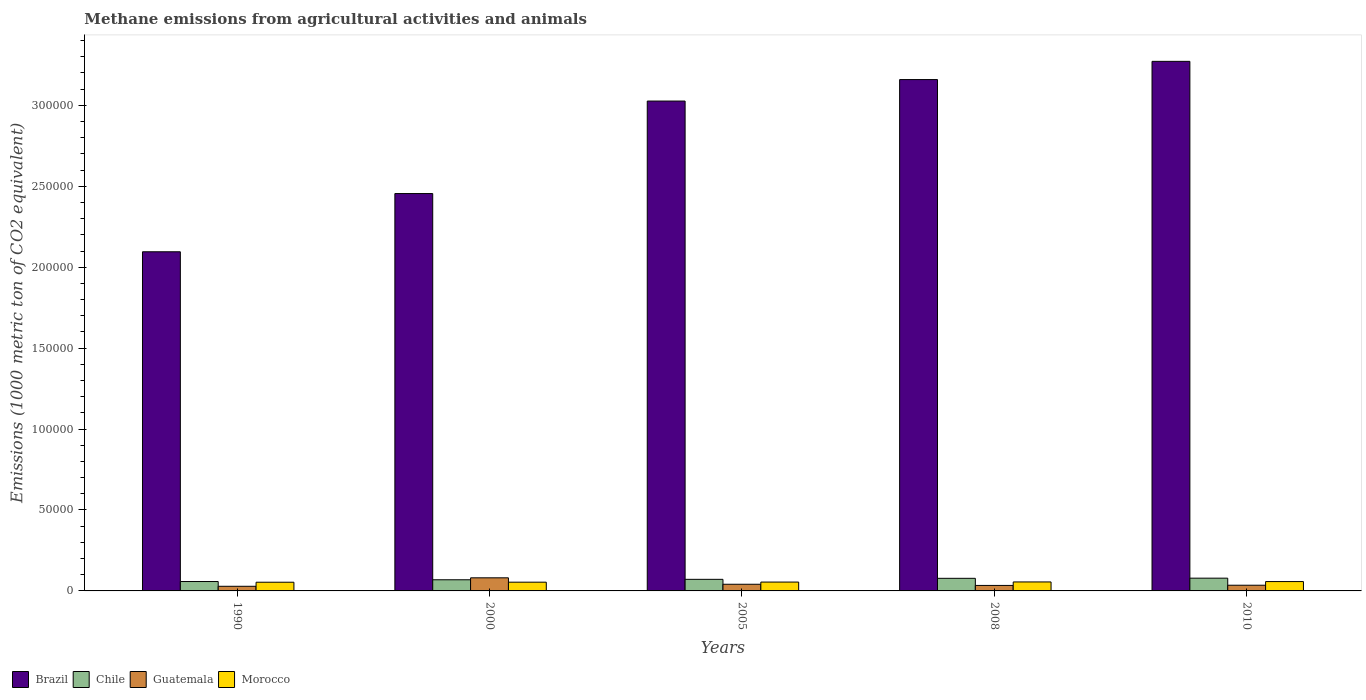How many different coloured bars are there?
Ensure brevity in your answer.  4. How many groups of bars are there?
Keep it short and to the point. 5. Are the number of bars per tick equal to the number of legend labels?
Ensure brevity in your answer.  Yes. Are the number of bars on each tick of the X-axis equal?
Provide a short and direct response. Yes. How many bars are there on the 1st tick from the left?
Provide a succinct answer. 4. What is the amount of methane emitted in Morocco in 1990?
Make the answer very short. 5368.8. Across all years, what is the maximum amount of methane emitted in Guatemala?
Give a very brief answer. 8089.2. Across all years, what is the minimum amount of methane emitted in Brazil?
Offer a terse response. 2.10e+05. What is the total amount of methane emitted in Guatemala in the graph?
Give a very brief answer. 2.20e+04. What is the difference between the amount of methane emitted in Guatemala in 1990 and that in 2010?
Your answer should be compact. -661. What is the difference between the amount of methane emitted in Brazil in 2008 and the amount of methane emitted in Morocco in 2010?
Your response must be concise. 3.10e+05. What is the average amount of methane emitted in Chile per year?
Offer a terse response. 7104.34. In the year 1990, what is the difference between the amount of methane emitted in Guatemala and amount of methane emitted in Morocco?
Keep it short and to the point. -2508.6. What is the ratio of the amount of methane emitted in Brazil in 2005 to that in 2008?
Your response must be concise. 0.96. Is the amount of methane emitted in Guatemala in 1990 less than that in 2000?
Your answer should be very brief. Yes. What is the difference between the highest and the second highest amount of methane emitted in Brazil?
Make the answer very short. 1.13e+04. What is the difference between the highest and the lowest amount of methane emitted in Morocco?
Ensure brevity in your answer.  410.3. Is the sum of the amount of methane emitted in Chile in 1990 and 2010 greater than the maximum amount of methane emitted in Guatemala across all years?
Provide a short and direct response. Yes. What does the 1st bar from the left in 1990 represents?
Make the answer very short. Brazil. Are all the bars in the graph horizontal?
Your response must be concise. No. How many years are there in the graph?
Provide a short and direct response. 5. Are the values on the major ticks of Y-axis written in scientific E-notation?
Provide a succinct answer. No. Does the graph contain any zero values?
Offer a terse response. No. Does the graph contain grids?
Offer a very short reply. No. Where does the legend appear in the graph?
Offer a terse response. Bottom left. What is the title of the graph?
Offer a terse response. Methane emissions from agricultural activities and animals. Does "Uganda" appear as one of the legend labels in the graph?
Ensure brevity in your answer.  No. What is the label or title of the Y-axis?
Provide a short and direct response. Emissions (1000 metric ton of CO2 equivalent). What is the Emissions (1000 metric ton of CO2 equivalent) of Brazil in 1990?
Your answer should be compact. 2.10e+05. What is the Emissions (1000 metric ton of CO2 equivalent) in Chile in 1990?
Give a very brief answer. 5805.8. What is the Emissions (1000 metric ton of CO2 equivalent) in Guatemala in 1990?
Offer a very short reply. 2860.2. What is the Emissions (1000 metric ton of CO2 equivalent) of Morocco in 1990?
Keep it short and to the point. 5368.8. What is the Emissions (1000 metric ton of CO2 equivalent) of Brazil in 2000?
Your answer should be very brief. 2.45e+05. What is the Emissions (1000 metric ton of CO2 equivalent) in Chile in 2000?
Provide a short and direct response. 6891.6. What is the Emissions (1000 metric ton of CO2 equivalent) of Guatemala in 2000?
Provide a succinct answer. 8089.2. What is the Emissions (1000 metric ton of CO2 equivalent) in Morocco in 2000?
Offer a terse response. 5400.3. What is the Emissions (1000 metric ton of CO2 equivalent) in Brazil in 2005?
Keep it short and to the point. 3.03e+05. What is the Emissions (1000 metric ton of CO2 equivalent) in Chile in 2005?
Offer a terse response. 7154.5. What is the Emissions (1000 metric ton of CO2 equivalent) of Guatemala in 2005?
Provide a short and direct response. 4120.8. What is the Emissions (1000 metric ton of CO2 equivalent) of Morocco in 2005?
Offer a terse response. 5471.4. What is the Emissions (1000 metric ton of CO2 equivalent) in Brazil in 2008?
Your response must be concise. 3.16e+05. What is the Emissions (1000 metric ton of CO2 equivalent) of Chile in 2008?
Offer a terse response. 7786.1. What is the Emissions (1000 metric ton of CO2 equivalent) in Guatemala in 2008?
Keep it short and to the point. 3394.9. What is the Emissions (1000 metric ton of CO2 equivalent) of Morocco in 2008?
Give a very brief answer. 5546.4. What is the Emissions (1000 metric ton of CO2 equivalent) of Brazil in 2010?
Offer a very short reply. 3.27e+05. What is the Emissions (1000 metric ton of CO2 equivalent) of Chile in 2010?
Your response must be concise. 7883.7. What is the Emissions (1000 metric ton of CO2 equivalent) of Guatemala in 2010?
Your answer should be compact. 3521.2. What is the Emissions (1000 metric ton of CO2 equivalent) in Morocco in 2010?
Offer a very short reply. 5779.1. Across all years, what is the maximum Emissions (1000 metric ton of CO2 equivalent) of Brazil?
Your response must be concise. 3.27e+05. Across all years, what is the maximum Emissions (1000 metric ton of CO2 equivalent) of Chile?
Offer a very short reply. 7883.7. Across all years, what is the maximum Emissions (1000 metric ton of CO2 equivalent) in Guatemala?
Give a very brief answer. 8089.2. Across all years, what is the maximum Emissions (1000 metric ton of CO2 equivalent) of Morocco?
Your answer should be compact. 5779.1. Across all years, what is the minimum Emissions (1000 metric ton of CO2 equivalent) in Brazil?
Provide a short and direct response. 2.10e+05. Across all years, what is the minimum Emissions (1000 metric ton of CO2 equivalent) in Chile?
Offer a very short reply. 5805.8. Across all years, what is the minimum Emissions (1000 metric ton of CO2 equivalent) in Guatemala?
Keep it short and to the point. 2860.2. Across all years, what is the minimum Emissions (1000 metric ton of CO2 equivalent) in Morocco?
Keep it short and to the point. 5368.8. What is the total Emissions (1000 metric ton of CO2 equivalent) in Brazil in the graph?
Offer a terse response. 1.40e+06. What is the total Emissions (1000 metric ton of CO2 equivalent) of Chile in the graph?
Give a very brief answer. 3.55e+04. What is the total Emissions (1000 metric ton of CO2 equivalent) of Guatemala in the graph?
Provide a short and direct response. 2.20e+04. What is the total Emissions (1000 metric ton of CO2 equivalent) of Morocco in the graph?
Provide a short and direct response. 2.76e+04. What is the difference between the Emissions (1000 metric ton of CO2 equivalent) of Brazil in 1990 and that in 2000?
Your answer should be compact. -3.60e+04. What is the difference between the Emissions (1000 metric ton of CO2 equivalent) in Chile in 1990 and that in 2000?
Keep it short and to the point. -1085.8. What is the difference between the Emissions (1000 metric ton of CO2 equivalent) in Guatemala in 1990 and that in 2000?
Give a very brief answer. -5229. What is the difference between the Emissions (1000 metric ton of CO2 equivalent) of Morocco in 1990 and that in 2000?
Offer a very short reply. -31.5. What is the difference between the Emissions (1000 metric ton of CO2 equivalent) in Brazil in 1990 and that in 2005?
Give a very brief answer. -9.31e+04. What is the difference between the Emissions (1000 metric ton of CO2 equivalent) in Chile in 1990 and that in 2005?
Your response must be concise. -1348.7. What is the difference between the Emissions (1000 metric ton of CO2 equivalent) in Guatemala in 1990 and that in 2005?
Offer a very short reply. -1260.6. What is the difference between the Emissions (1000 metric ton of CO2 equivalent) of Morocco in 1990 and that in 2005?
Your answer should be compact. -102.6. What is the difference between the Emissions (1000 metric ton of CO2 equivalent) in Brazil in 1990 and that in 2008?
Make the answer very short. -1.06e+05. What is the difference between the Emissions (1000 metric ton of CO2 equivalent) of Chile in 1990 and that in 2008?
Make the answer very short. -1980.3. What is the difference between the Emissions (1000 metric ton of CO2 equivalent) of Guatemala in 1990 and that in 2008?
Make the answer very short. -534.7. What is the difference between the Emissions (1000 metric ton of CO2 equivalent) of Morocco in 1990 and that in 2008?
Your response must be concise. -177.6. What is the difference between the Emissions (1000 metric ton of CO2 equivalent) in Brazil in 1990 and that in 2010?
Your answer should be very brief. -1.18e+05. What is the difference between the Emissions (1000 metric ton of CO2 equivalent) of Chile in 1990 and that in 2010?
Your answer should be very brief. -2077.9. What is the difference between the Emissions (1000 metric ton of CO2 equivalent) of Guatemala in 1990 and that in 2010?
Keep it short and to the point. -661. What is the difference between the Emissions (1000 metric ton of CO2 equivalent) in Morocco in 1990 and that in 2010?
Provide a short and direct response. -410.3. What is the difference between the Emissions (1000 metric ton of CO2 equivalent) in Brazil in 2000 and that in 2005?
Give a very brief answer. -5.71e+04. What is the difference between the Emissions (1000 metric ton of CO2 equivalent) in Chile in 2000 and that in 2005?
Your answer should be compact. -262.9. What is the difference between the Emissions (1000 metric ton of CO2 equivalent) of Guatemala in 2000 and that in 2005?
Give a very brief answer. 3968.4. What is the difference between the Emissions (1000 metric ton of CO2 equivalent) in Morocco in 2000 and that in 2005?
Your answer should be very brief. -71.1. What is the difference between the Emissions (1000 metric ton of CO2 equivalent) in Brazil in 2000 and that in 2008?
Your response must be concise. -7.04e+04. What is the difference between the Emissions (1000 metric ton of CO2 equivalent) in Chile in 2000 and that in 2008?
Provide a short and direct response. -894.5. What is the difference between the Emissions (1000 metric ton of CO2 equivalent) in Guatemala in 2000 and that in 2008?
Offer a terse response. 4694.3. What is the difference between the Emissions (1000 metric ton of CO2 equivalent) in Morocco in 2000 and that in 2008?
Give a very brief answer. -146.1. What is the difference between the Emissions (1000 metric ton of CO2 equivalent) of Brazil in 2000 and that in 2010?
Your response must be concise. -8.17e+04. What is the difference between the Emissions (1000 metric ton of CO2 equivalent) of Chile in 2000 and that in 2010?
Your answer should be compact. -992.1. What is the difference between the Emissions (1000 metric ton of CO2 equivalent) of Guatemala in 2000 and that in 2010?
Provide a succinct answer. 4568. What is the difference between the Emissions (1000 metric ton of CO2 equivalent) of Morocco in 2000 and that in 2010?
Your response must be concise. -378.8. What is the difference between the Emissions (1000 metric ton of CO2 equivalent) in Brazil in 2005 and that in 2008?
Provide a short and direct response. -1.33e+04. What is the difference between the Emissions (1000 metric ton of CO2 equivalent) of Chile in 2005 and that in 2008?
Make the answer very short. -631.6. What is the difference between the Emissions (1000 metric ton of CO2 equivalent) of Guatemala in 2005 and that in 2008?
Offer a terse response. 725.9. What is the difference between the Emissions (1000 metric ton of CO2 equivalent) in Morocco in 2005 and that in 2008?
Offer a very short reply. -75. What is the difference between the Emissions (1000 metric ton of CO2 equivalent) in Brazil in 2005 and that in 2010?
Make the answer very short. -2.45e+04. What is the difference between the Emissions (1000 metric ton of CO2 equivalent) of Chile in 2005 and that in 2010?
Your answer should be very brief. -729.2. What is the difference between the Emissions (1000 metric ton of CO2 equivalent) in Guatemala in 2005 and that in 2010?
Give a very brief answer. 599.6. What is the difference between the Emissions (1000 metric ton of CO2 equivalent) in Morocco in 2005 and that in 2010?
Make the answer very short. -307.7. What is the difference between the Emissions (1000 metric ton of CO2 equivalent) of Brazil in 2008 and that in 2010?
Offer a very short reply. -1.13e+04. What is the difference between the Emissions (1000 metric ton of CO2 equivalent) in Chile in 2008 and that in 2010?
Offer a very short reply. -97.6. What is the difference between the Emissions (1000 metric ton of CO2 equivalent) of Guatemala in 2008 and that in 2010?
Ensure brevity in your answer.  -126.3. What is the difference between the Emissions (1000 metric ton of CO2 equivalent) of Morocco in 2008 and that in 2010?
Give a very brief answer. -232.7. What is the difference between the Emissions (1000 metric ton of CO2 equivalent) in Brazil in 1990 and the Emissions (1000 metric ton of CO2 equivalent) in Chile in 2000?
Your response must be concise. 2.03e+05. What is the difference between the Emissions (1000 metric ton of CO2 equivalent) in Brazil in 1990 and the Emissions (1000 metric ton of CO2 equivalent) in Guatemala in 2000?
Ensure brevity in your answer.  2.01e+05. What is the difference between the Emissions (1000 metric ton of CO2 equivalent) in Brazil in 1990 and the Emissions (1000 metric ton of CO2 equivalent) in Morocco in 2000?
Offer a very short reply. 2.04e+05. What is the difference between the Emissions (1000 metric ton of CO2 equivalent) of Chile in 1990 and the Emissions (1000 metric ton of CO2 equivalent) of Guatemala in 2000?
Your response must be concise. -2283.4. What is the difference between the Emissions (1000 metric ton of CO2 equivalent) of Chile in 1990 and the Emissions (1000 metric ton of CO2 equivalent) of Morocco in 2000?
Offer a very short reply. 405.5. What is the difference between the Emissions (1000 metric ton of CO2 equivalent) in Guatemala in 1990 and the Emissions (1000 metric ton of CO2 equivalent) in Morocco in 2000?
Offer a terse response. -2540.1. What is the difference between the Emissions (1000 metric ton of CO2 equivalent) of Brazil in 1990 and the Emissions (1000 metric ton of CO2 equivalent) of Chile in 2005?
Offer a terse response. 2.02e+05. What is the difference between the Emissions (1000 metric ton of CO2 equivalent) in Brazil in 1990 and the Emissions (1000 metric ton of CO2 equivalent) in Guatemala in 2005?
Make the answer very short. 2.05e+05. What is the difference between the Emissions (1000 metric ton of CO2 equivalent) of Brazil in 1990 and the Emissions (1000 metric ton of CO2 equivalent) of Morocco in 2005?
Provide a succinct answer. 2.04e+05. What is the difference between the Emissions (1000 metric ton of CO2 equivalent) of Chile in 1990 and the Emissions (1000 metric ton of CO2 equivalent) of Guatemala in 2005?
Your answer should be compact. 1685. What is the difference between the Emissions (1000 metric ton of CO2 equivalent) of Chile in 1990 and the Emissions (1000 metric ton of CO2 equivalent) of Morocco in 2005?
Offer a very short reply. 334.4. What is the difference between the Emissions (1000 metric ton of CO2 equivalent) in Guatemala in 1990 and the Emissions (1000 metric ton of CO2 equivalent) in Morocco in 2005?
Your answer should be compact. -2611.2. What is the difference between the Emissions (1000 metric ton of CO2 equivalent) of Brazil in 1990 and the Emissions (1000 metric ton of CO2 equivalent) of Chile in 2008?
Your answer should be very brief. 2.02e+05. What is the difference between the Emissions (1000 metric ton of CO2 equivalent) of Brazil in 1990 and the Emissions (1000 metric ton of CO2 equivalent) of Guatemala in 2008?
Ensure brevity in your answer.  2.06e+05. What is the difference between the Emissions (1000 metric ton of CO2 equivalent) in Brazil in 1990 and the Emissions (1000 metric ton of CO2 equivalent) in Morocco in 2008?
Provide a short and direct response. 2.04e+05. What is the difference between the Emissions (1000 metric ton of CO2 equivalent) in Chile in 1990 and the Emissions (1000 metric ton of CO2 equivalent) in Guatemala in 2008?
Provide a short and direct response. 2410.9. What is the difference between the Emissions (1000 metric ton of CO2 equivalent) in Chile in 1990 and the Emissions (1000 metric ton of CO2 equivalent) in Morocco in 2008?
Provide a short and direct response. 259.4. What is the difference between the Emissions (1000 metric ton of CO2 equivalent) in Guatemala in 1990 and the Emissions (1000 metric ton of CO2 equivalent) in Morocco in 2008?
Offer a very short reply. -2686.2. What is the difference between the Emissions (1000 metric ton of CO2 equivalent) in Brazil in 1990 and the Emissions (1000 metric ton of CO2 equivalent) in Chile in 2010?
Offer a terse response. 2.02e+05. What is the difference between the Emissions (1000 metric ton of CO2 equivalent) of Brazil in 1990 and the Emissions (1000 metric ton of CO2 equivalent) of Guatemala in 2010?
Give a very brief answer. 2.06e+05. What is the difference between the Emissions (1000 metric ton of CO2 equivalent) in Brazil in 1990 and the Emissions (1000 metric ton of CO2 equivalent) in Morocco in 2010?
Offer a very short reply. 2.04e+05. What is the difference between the Emissions (1000 metric ton of CO2 equivalent) in Chile in 1990 and the Emissions (1000 metric ton of CO2 equivalent) in Guatemala in 2010?
Keep it short and to the point. 2284.6. What is the difference between the Emissions (1000 metric ton of CO2 equivalent) in Chile in 1990 and the Emissions (1000 metric ton of CO2 equivalent) in Morocco in 2010?
Your answer should be compact. 26.7. What is the difference between the Emissions (1000 metric ton of CO2 equivalent) of Guatemala in 1990 and the Emissions (1000 metric ton of CO2 equivalent) of Morocco in 2010?
Offer a very short reply. -2918.9. What is the difference between the Emissions (1000 metric ton of CO2 equivalent) in Brazil in 2000 and the Emissions (1000 metric ton of CO2 equivalent) in Chile in 2005?
Your response must be concise. 2.38e+05. What is the difference between the Emissions (1000 metric ton of CO2 equivalent) of Brazil in 2000 and the Emissions (1000 metric ton of CO2 equivalent) of Guatemala in 2005?
Offer a very short reply. 2.41e+05. What is the difference between the Emissions (1000 metric ton of CO2 equivalent) in Brazil in 2000 and the Emissions (1000 metric ton of CO2 equivalent) in Morocco in 2005?
Offer a very short reply. 2.40e+05. What is the difference between the Emissions (1000 metric ton of CO2 equivalent) of Chile in 2000 and the Emissions (1000 metric ton of CO2 equivalent) of Guatemala in 2005?
Provide a succinct answer. 2770.8. What is the difference between the Emissions (1000 metric ton of CO2 equivalent) of Chile in 2000 and the Emissions (1000 metric ton of CO2 equivalent) of Morocco in 2005?
Your response must be concise. 1420.2. What is the difference between the Emissions (1000 metric ton of CO2 equivalent) in Guatemala in 2000 and the Emissions (1000 metric ton of CO2 equivalent) in Morocco in 2005?
Keep it short and to the point. 2617.8. What is the difference between the Emissions (1000 metric ton of CO2 equivalent) in Brazil in 2000 and the Emissions (1000 metric ton of CO2 equivalent) in Chile in 2008?
Offer a very short reply. 2.38e+05. What is the difference between the Emissions (1000 metric ton of CO2 equivalent) of Brazil in 2000 and the Emissions (1000 metric ton of CO2 equivalent) of Guatemala in 2008?
Offer a terse response. 2.42e+05. What is the difference between the Emissions (1000 metric ton of CO2 equivalent) in Brazil in 2000 and the Emissions (1000 metric ton of CO2 equivalent) in Morocco in 2008?
Provide a succinct answer. 2.40e+05. What is the difference between the Emissions (1000 metric ton of CO2 equivalent) of Chile in 2000 and the Emissions (1000 metric ton of CO2 equivalent) of Guatemala in 2008?
Keep it short and to the point. 3496.7. What is the difference between the Emissions (1000 metric ton of CO2 equivalent) in Chile in 2000 and the Emissions (1000 metric ton of CO2 equivalent) in Morocco in 2008?
Provide a short and direct response. 1345.2. What is the difference between the Emissions (1000 metric ton of CO2 equivalent) of Guatemala in 2000 and the Emissions (1000 metric ton of CO2 equivalent) of Morocco in 2008?
Keep it short and to the point. 2542.8. What is the difference between the Emissions (1000 metric ton of CO2 equivalent) in Brazil in 2000 and the Emissions (1000 metric ton of CO2 equivalent) in Chile in 2010?
Provide a short and direct response. 2.38e+05. What is the difference between the Emissions (1000 metric ton of CO2 equivalent) of Brazil in 2000 and the Emissions (1000 metric ton of CO2 equivalent) of Guatemala in 2010?
Your answer should be compact. 2.42e+05. What is the difference between the Emissions (1000 metric ton of CO2 equivalent) in Brazil in 2000 and the Emissions (1000 metric ton of CO2 equivalent) in Morocco in 2010?
Your answer should be very brief. 2.40e+05. What is the difference between the Emissions (1000 metric ton of CO2 equivalent) of Chile in 2000 and the Emissions (1000 metric ton of CO2 equivalent) of Guatemala in 2010?
Give a very brief answer. 3370.4. What is the difference between the Emissions (1000 metric ton of CO2 equivalent) in Chile in 2000 and the Emissions (1000 metric ton of CO2 equivalent) in Morocco in 2010?
Your answer should be very brief. 1112.5. What is the difference between the Emissions (1000 metric ton of CO2 equivalent) of Guatemala in 2000 and the Emissions (1000 metric ton of CO2 equivalent) of Morocco in 2010?
Offer a terse response. 2310.1. What is the difference between the Emissions (1000 metric ton of CO2 equivalent) of Brazil in 2005 and the Emissions (1000 metric ton of CO2 equivalent) of Chile in 2008?
Make the answer very short. 2.95e+05. What is the difference between the Emissions (1000 metric ton of CO2 equivalent) of Brazil in 2005 and the Emissions (1000 metric ton of CO2 equivalent) of Guatemala in 2008?
Your answer should be very brief. 2.99e+05. What is the difference between the Emissions (1000 metric ton of CO2 equivalent) in Brazil in 2005 and the Emissions (1000 metric ton of CO2 equivalent) in Morocco in 2008?
Offer a terse response. 2.97e+05. What is the difference between the Emissions (1000 metric ton of CO2 equivalent) of Chile in 2005 and the Emissions (1000 metric ton of CO2 equivalent) of Guatemala in 2008?
Your answer should be very brief. 3759.6. What is the difference between the Emissions (1000 metric ton of CO2 equivalent) in Chile in 2005 and the Emissions (1000 metric ton of CO2 equivalent) in Morocco in 2008?
Provide a succinct answer. 1608.1. What is the difference between the Emissions (1000 metric ton of CO2 equivalent) in Guatemala in 2005 and the Emissions (1000 metric ton of CO2 equivalent) in Morocco in 2008?
Provide a succinct answer. -1425.6. What is the difference between the Emissions (1000 metric ton of CO2 equivalent) of Brazil in 2005 and the Emissions (1000 metric ton of CO2 equivalent) of Chile in 2010?
Keep it short and to the point. 2.95e+05. What is the difference between the Emissions (1000 metric ton of CO2 equivalent) in Brazil in 2005 and the Emissions (1000 metric ton of CO2 equivalent) in Guatemala in 2010?
Ensure brevity in your answer.  2.99e+05. What is the difference between the Emissions (1000 metric ton of CO2 equivalent) of Brazil in 2005 and the Emissions (1000 metric ton of CO2 equivalent) of Morocco in 2010?
Make the answer very short. 2.97e+05. What is the difference between the Emissions (1000 metric ton of CO2 equivalent) in Chile in 2005 and the Emissions (1000 metric ton of CO2 equivalent) in Guatemala in 2010?
Give a very brief answer. 3633.3. What is the difference between the Emissions (1000 metric ton of CO2 equivalent) in Chile in 2005 and the Emissions (1000 metric ton of CO2 equivalent) in Morocco in 2010?
Make the answer very short. 1375.4. What is the difference between the Emissions (1000 metric ton of CO2 equivalent) in Guatemala in 2005 and the Emissions (1000 metric ton of CO2 equivalent) in Morocco in 2010?
Keep it short and to the point. -1658.3. What is the difference between the Emissions (1000 metric ton of CO2 equivalent) of Brazil in 2008 and the Emissions (1000 metric ton of CO2 equivalent) of Chile in 2010?
Your answer should be compact. 3.08e+05. What is the difference between the Emissions (1000 metric ton of CO2 equivalent) in Brazil in 2008 and the Emissions (1000 metric ton of CO2 equivalent) in Guatemala in 2010?
Ensure brevity in your answer.  3.12e+05. What is the difference between the Emissions (1000 metric ton of CO2 equivalent) in Brazil in 2008 and the Emissions (1000 metric ton of CO2 equivalent) in Morocco in 2010?
Ensure brevity in your answer.  3.10e+05. What is the difference between the Emissions (1000 metric ton of CO2 equivalent) of Chile in 2008 and the Emissions (1000 metric ton of CO2 equivalent) of Guatemala in 2010?
Give a very brief answer. 4264.9. What is the difference between the Emissions (1000 metric ton of CO2 equivalent) in Chile in 2008 and the Emissions (1000 metric ton of CO2 equivalent) in Morocco in 2010?
Your answer should be compact. 2007. What is the difference between the Emissions (1000 metric ton of CO2 equivalent) of Guatemala in 2008 and the Emissions (1000 metric ton of CO2 equivalent) of Morocco in 2010?
Provide a succinct answer. -2384.2. What is the average Emissions (1000 metric ton of CO2 equivalent) in Brazil per year?
Ensure brevity in your answer.  2.80e+05. What is the average Emissions (1000 metric ton of CO2 equivalent) in Chile per year?
Offer a very short reply. 7104.34. What is the average Emissions (1000 metric ton of CO2 equivalent) in Guatemala per year?
Keep it short and to the point. 4397.26. What is the average Emissions (1000 metric ton of CO2 equivalent) of Morocco per year?
Offer a very short reply. 5513.2. In the year 1990, what is the difference between the Emissions (1000 metric ton of CO2 equivalent) in Brazil and Emissions (1000 metric ton of CO2 equivalent) in Chile?
Your answer should be very brief. 2.04e+05. In the year 1990, what is the difference between the Emissions (1000 metric ton of CO2 equivalent) of Brazil and Emissions (1000 metric ton of CO2 equivalent) of Guatemala?
Make the answer very short. 2.07e+05. In the year 1990, what is the difference between the Emissions (1000 metric ton of CO2 equivalent) of Brazil and Emissions (1000 metric ton of CO2 equivalent) of Morocco?
Offer a terse response. 2.04e+05. In the year 1990, what is the difference between the Emissions (1000 metric ton of CO2 equivalent) of Chile and Emissions (1000 metric ton of CO2 equivalent) of Guatemala?
Offer a terse response. 2945.6. In the year 1990, what is the difference between the Emissions (1000 metric ton of CO2 equivalent) of Chile and Emissions (1000 metric ton of CO2 equivalent) of Morocco?
Ensure brevity in your answer.  437. In the year 1990, what is the difference between the Emissions (1000 metric ton of CO2 equivalent) in Guatemala and Emissions (1000 metric ton of CO2 equivalent) in Morocco?
Provide a short and direct response. -2508.6. In the year 2000, what is the difference between the Emissions (1000 metric ton of CO2 equivalent) of Brazil and Emissions (1000 metric ton of CO2 equivalent) of Chile?
Your response must be concise. 2.39e+05. In the year 2000, what is the difference between the Emissions (1000 metric ton of CO2 equivalent) in Brazil and Emissions (1000 metric ton of CO2 equivalent) in Guatemala?
Your response must be concise. 2.37e+05. In the year 2000, what is the difference between the Emissions (1000 metric ton of CO2 equivalent) in Brazil and Emissions (1000 metric ton of CO2 equivalent) in Morocco?
Make the answer very short. 2.40e+05. In the year 2000, what is the difference between the Emissions (1000 metric ton of CO2 equivalent) of Chile and Emissions (1000 metric ton of CO2 equivalent) of Guatemala?
Your answer should be very brief. -1197.6. In the year 2000, what is the difference between the Emissions (1000 metric ton of CO2 equivalent) of Chile and Emissions (1000 metric ton of CO2 equivalent) of Morocco?
Provide a short and direct response. 1491.3. In the year 2000, what is the difference between the Emissions (1000 metric ton of CO2 equivalent) of Guatemala and Emissions (1000 metric ton of CO2 equivalent) of Morocco?
Provide a succinct answer. 2688.9. In the year 2005, what is the difference between the Emissions (1000 metric ton of CO2 equivalent) in Brazil and Emissions (1000 metric ton of CO2 equivalent) in Chile?
Your response must be concise. 2.95e+05. In the year 2005, what is the difference between the Emissions (1000 metric ton of CO2 equivalent) of Brazil and Emissions (1000 metric ton of CO2 equivalent) of Guatemala?
Make the answer very short. 2.99e+05. In the year 2005, what is the difference between the Emissions (1000 metric ton of CO2 equivalent) of Brazil and Emissions (1000 metric ton of CO2 equivalent) of Morocco?
Provide a short and direct response. 2.97e+05. In the year 2005, what is the difference between the Emissions (1000 metric ton of CO2 equivalent) in Chile and Emissions (1000 metric ton of CO2 equivalent) in Guatemala?
Provide a succinct answer. 3033.7. In the year 2005, what is the difference between the Emissions (1000 metric ton of CO2 equivalent) of Chile and Emissions (1000 metric ton of CO2 equivalent) of Morocco?
Offer a very short reply. 1683.1. In the year 2005, what is the difference between the Emissions (1000 metric ton of CO2 equivalent) in Guatemala and Emissions (1000 metric ton of CO2 equivalent) in Morocco?
Your response must be concise. -1350.6. In the year 2008, what is the difference between the Emissions (1000 metric ton of CO2 equivalent) in Brazil and Emissions (1000 metric ton of CO2 equivalent) in Chile?
Ensure brevity in your answer.  3.08e+05. In the year 2008, what is the difference between the Emissions (1000 metric ton of CO2 equivalent) in Brazil and Emissions (1000 metric ton of CO2 equivalent) in Guatemala?
Give a very brief answer. 3.13e+05. In the year 2008, what is the difference between the Emissions (1000 metric ton of CO2 equivalent) of Brazil and Emissions (1000 metric ton of CO2 equivalent) of Morocco?
Give a very brief answer. 3.10e+05. In the year 2008, what is the difference between the Emissions (1000 metric ton of CO2 equivalent) in Chile and Emissions (1000 metric ton of CO2 equivalent) in Guatemala?
Offer a very short reply. 4391.2. In the year 2008, what is the difference between the Emissions (1000 metric ton of CO2 equivalent) in Chile and Emissions (1000 metric ton of CO2 equivalent) in Morocco?
Your answer should be very brief. 2239.7. In the year 2008, what is the difference between the Emissions (1000 metric ton of CO2 equivalent) of Guatemala and Emissions (1000 metric ton of CO2 equivalent) of Morocco?
Your answer should be very brief. -2151.5. In the year 2010, what is the difference between the Emissions (1000 metric ton of CO2 equivalent) in Brazil and Emissions (1000 metric ton of CO2 equivalent) in Chile?
Keep it short and to the point. 3.19e+05. In the year 2010, what is the difference between the Emissions (1000 metric ton of CO2 equivalent) of Brazil and Emissions (1000 metric ton of CO2 equivalent) of Guatemala?
Offer a very short reply. 3.24e+05. In the year 2010, what is the difference between the Emissions (1000 metric ton of CO2 equivalent) in Brazil and Emissions (1000 metric ton of CO2 equivalent) in Morocco?
Make the answer very short. 3.21e+05. In the year 2010, what is the difference between the Emissions (1000 metric ton of CO2 equivalent) in Chile and Emissions (1000 metric ton of CO2 equivalent) in Guatemala?
Offer a very short reply. 4362.5. In the year 2010, what is the difference between the Emissions (1000 metric ton of CO2 equivalent) in Chile and Emissions (1000 metric ton of CO2 equivalent) in Morocco?
Provide a short and direct response. 2104.6. In the year 2010, what is the difference between the Emissions (1000 metric ton of CO2 equivalent) in Guatemala and Emissions (1000 metric ton of CO2 equivalent) in Morocco?
Give a very brief answer. -2257.9. What is the ratio of the Emissions (1000 metric ton of CO2 equivalent) in Brazil in 1990 to that in 2000?
Offer a very short reply. 0.85. What is the ratio of the Emissions (1000 metric ton of CO2 equivalent) of Chile in 1990 to that in 2000?
Keep it short and to the point. 0.84. What is the ratio of the Emissions (1000 metric ton of CO2 equivalent) in Guatemala in 1990 to that in 2000?
Keep it short and to the point. 0.35. What is the ratio of the Emissions (1000 metric ton of CO2 equivalent) in Brazil in 1990 to that in 2005?
Give a very brief answer. 0.69. What is the ratio of the Emissions (1000 metric ton of CO2 equivalent) of Chile in 1990 to that in 2005?
Provide a succinct answer. 0.81. What is the ratio of the Emissions (1000 metric ton of CO2 equivalent) of Guatemala in 1990 to that in 2005?
Give a very brief answer. 0.69. What is the ratio of the Emissions (1000 metric ton of CO2 equivalent) in Morocco in 1990 to that in 2005?
Ensure brevity in your answer.  0.98. What is the ratio of the Emissions (1000 metric ton of CO2 equivalent) in Brazil in 1990 to that in 2008?
Give a very brief answer. 0.66. What is the ratio of the Emissions (1000 metric ton of CO2 equivalent) in Chile in 1990 to that in 2008?
Ensure brevity in your answer.  0.75. What is the ratio of the Emissions (1000 metric ton of CO2 equivalent) of Guatemala in 1990 to that in 2008?
Your response must be concise. 0.84. What is the ratio of the Emissions (1000 metric ton of CO2 equivalent) in Morocco in 1990 to that in 2008?
Give a very brief answer. 0.97. What is the ratio of the Emissions (1000 metric ton of CO2 equivalent) in Brazil in 1990 to that in 2010?
Provide a succinct answer. 0.64. What is the ratio of the Emissions (1000 metric ton of CO2 equivalent) of Chile in 1990 to that in 2010?
Provide a short and direct response. 0.74. What is the ratio of the Emissions (1000 metric ton of CO2 equivalent) of Guatemala in 1990 to that in 2010?
Keep it short and to the point. 0.81. What is the ratio of the Emissions (1000 metric ton of CO2 equivalent) in Morocco in 1990 to that in 2010?
Your response must be concise. 0.93. What is the ratio of the Emissions (1000 metric ton of CO2 equivalent) of Brazil in 2000 to that in 2005?
Offer a very short reply. 0.81. What is the ratio of the Emissions (1000 metric ton of CO2 equivalent) of Chile in 2000 to that in 2005?
Give a very brief answer. 0.96. What is the ratio of the Emissions (1000 metric ton of CO2 equivalent) of Guatemala in 2000 to that in 2005?
Ensure brevity in your answer.  1.96. What is the ratio of the Emissions (1000 metric ton of CO2 equivalent) of Morocco in 2000 to that in 2005?
Your answer should be compact. 0.99. What is the ratio of the Emissions (1000 metric ton of CO2 equivalent) in Brazil in 2000 to that in 2008?
Provide a succinct answer. 0.78. What is the ratio of the Emissions (1000 metric ton of CO2 equivalent) of Chile in 2000 to that in 2008?
Ensure brevity in your answer.  0.89. What is the ratio of the Emissions (1000 metric ton of CO2 equivalent) of Guatemala in 2000 to that in 2008?
Make the answer very short. 2.38. What is the ratio of the Emissions (1000 metric ton of CO2 equivalent) of Morocco in 2000 to that in 2008?
Make the answer very short. 0.97. What is the ratio of the Emissions (1000 metric ton of CO2 equivalent) of Brazil in 2000 to that in 2010?
Provide a short and direct response. 0.75. What is the ratio of the Emissions (1000 metric ton of CO2 equivalent) in Chile in 2000 to that in 2010?
Keep it short and to the point. 0.87. What is the ratio of the Emissions (1000 metric ton of CO2 equivalent) of Guatemala in 2000 to that in 2010?
Your response must be concise. 2.3. What is the ratio of the Emissions (1000 metric ton of CO2 equivalent) in Morocco in 2000 to that in 2010?
Keep it short and to the point. 0.93. What is the ratio of the Emissions (1000 metric ton of CO2 equivalent) in Brazil in 2005 to that in 2008?
Keep it short and to the point. 0.96. What is the ratio of the Emissions (1000 metric ton of CO2 equivalent) in Chile in 2005 to that in 2008?
Make the answer very short. 0.92. What is the ratio of the Emissions (1000 metric ton of CO2 equivalent) in Guatemala in 2005 to that in 2008?
Offer a terse response. 1.21. What is the ratio of the Emissions (1000 metric ton of CO2 equivalent) in Morocco in 2005 to that in 2008?
Provide a succinct answer. 0.99. What is the ratio of the Emissions (1000 metric ton of CO2 equivalent) in Brazil in 2005 to that in 2010?
Offer a terse response. 0.93. What is the ratio of the Emissions (1000 metric ton of CO2 equivalent) of Chile in 2005 to that in 2010?
Offer a very short reply. 0.91. What is the ratio of the Emissions (1000 metric ton of CO2 equivalent) of Guatemala in 2005 to that in 2010?
Your answer should be compact. 1.17. What is the ratio of the Emissions (1000 metric ton of CO2 equivalent) in Morocco in 2005 to that in 2010?
Ensure brevity in your answer.  0.95. What is the ratio of the Emissions (1000 metric ton of CO2 equivalent) in Brazil in 2008 to that in 2010?
Keep it short and to the point. 0.97. What is the ratio of the Emissions (1000 metric ton of CO2 equivalent) of Chile in 2008 to that in 2010?
Provide a succinct answer. 0.99. What is the ratio of the Emissions (1000 metric ton of CO2 equivalent) of Guatemala in 2008 to that in 2010?
Your response must be concise. 0.96. What is the ratio of the Emissions (1000 metric ton of CO2 equivalent) of Morocco in 2008 to that in 2010?
Give a very brief answer. 0.96. What is the difference between the highest and the second highest Emissions (1000 metric ton of CO2 equivalent) in Brazil?
Offer a very short reply. 1.13e+04. What is the difference between the highest and the second highest Emissions (1000 metric ton of CO2 equivalent) in Chile?
Offer a very short reply. 97.6. What is the difference between the highest and the second highest Emissions (1000 metric ton of CO2 equivalent) of Guatemala?
Provide a succinct answer. 3968.4. What is the difference between the highest and the second highest Emissions (1000 metric ton of CO2 equivalent) in Morocco?
Offer a very short reply. 232.7. What is the difference between the highest and the lowest Emissions (1000 metric ton of CO2 equivalent) in Brazil?
Your response must be concise. 1.18e+05. What is the difference between the highest and the lowest Emissions (1000 metric ton of CO2 equivalent) of Chile?
Ensure brevity in your answer.  2077.9. What is the difference between the highest and the lowest Emissions (1000 metric ton of CO2 equivalent) of Guatemala?
Offer a terse response. 5229. What is the difference between the highest and the lowest Emissions (1000 metric ton of CO2 equivalent) in Morocco?
Give a very brief answer. 410.3. 